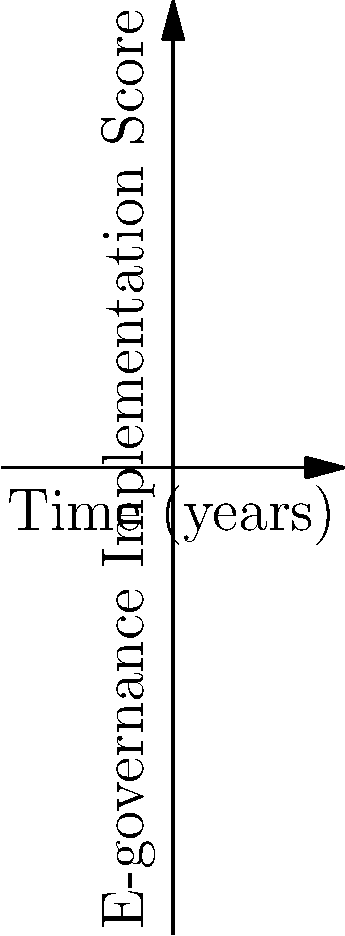The graph shows the e-governance implementation scores for three Indian states over a 5-year period. Based on the polynomial trends, which state is likely to have the highest e-governance implementation score after 10 years, and what factors might contribute to this projection? To determine which state will likely have the highest e-governance implementation score after 10 years, we need to analyze the trends:

1. Identify the polynomials:
   State A: $f(x) = 0.5x^3 - 2x^2 + 2x + 10$ (blue)
   State B: $g(x) = -0.25x^3 + x^2 + 5x + 5$ (red)
   State C: $h(x) = 0.1x^3 + x^2 - x + 15$ (green)

2. Analyze the leading terms:
   State A: $0.5x^3$ (positive, highest coefficient)
   State B: $-0.25x^3$ (negative)
   State C: $0.1x^3$ (positive, but smaller coefficient than A)

3. Extrapolate trends:
   State A will grow the fastest due to its positive and highest cubic term.
   State B will eventually decrease due to its negative cubic term.
   State C will grow, but slower than State A.

4. Consider factors contributing to this projection:
   - Consistent investment in IT infrastructure
   - Effective policy implementation
   - Skilled workforce development
   - Public-private partnerships
   - Citizen engagement and digital literacy programs

Therefore, State A is likely to have the highest e-governance implementation score after 10 years.
Answer: State A, due to its positive cubic growth trend, likely driven by consistent investment and effective policy implementation. 